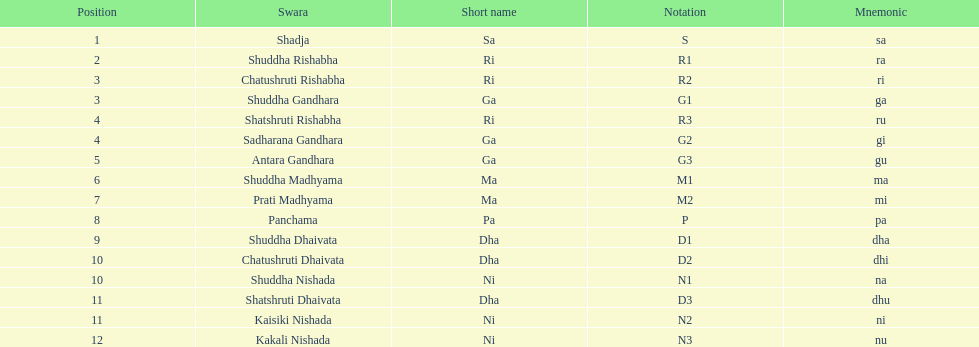What is the appellation of the swara succeeding panchama? Shuddha Dhaivata. 